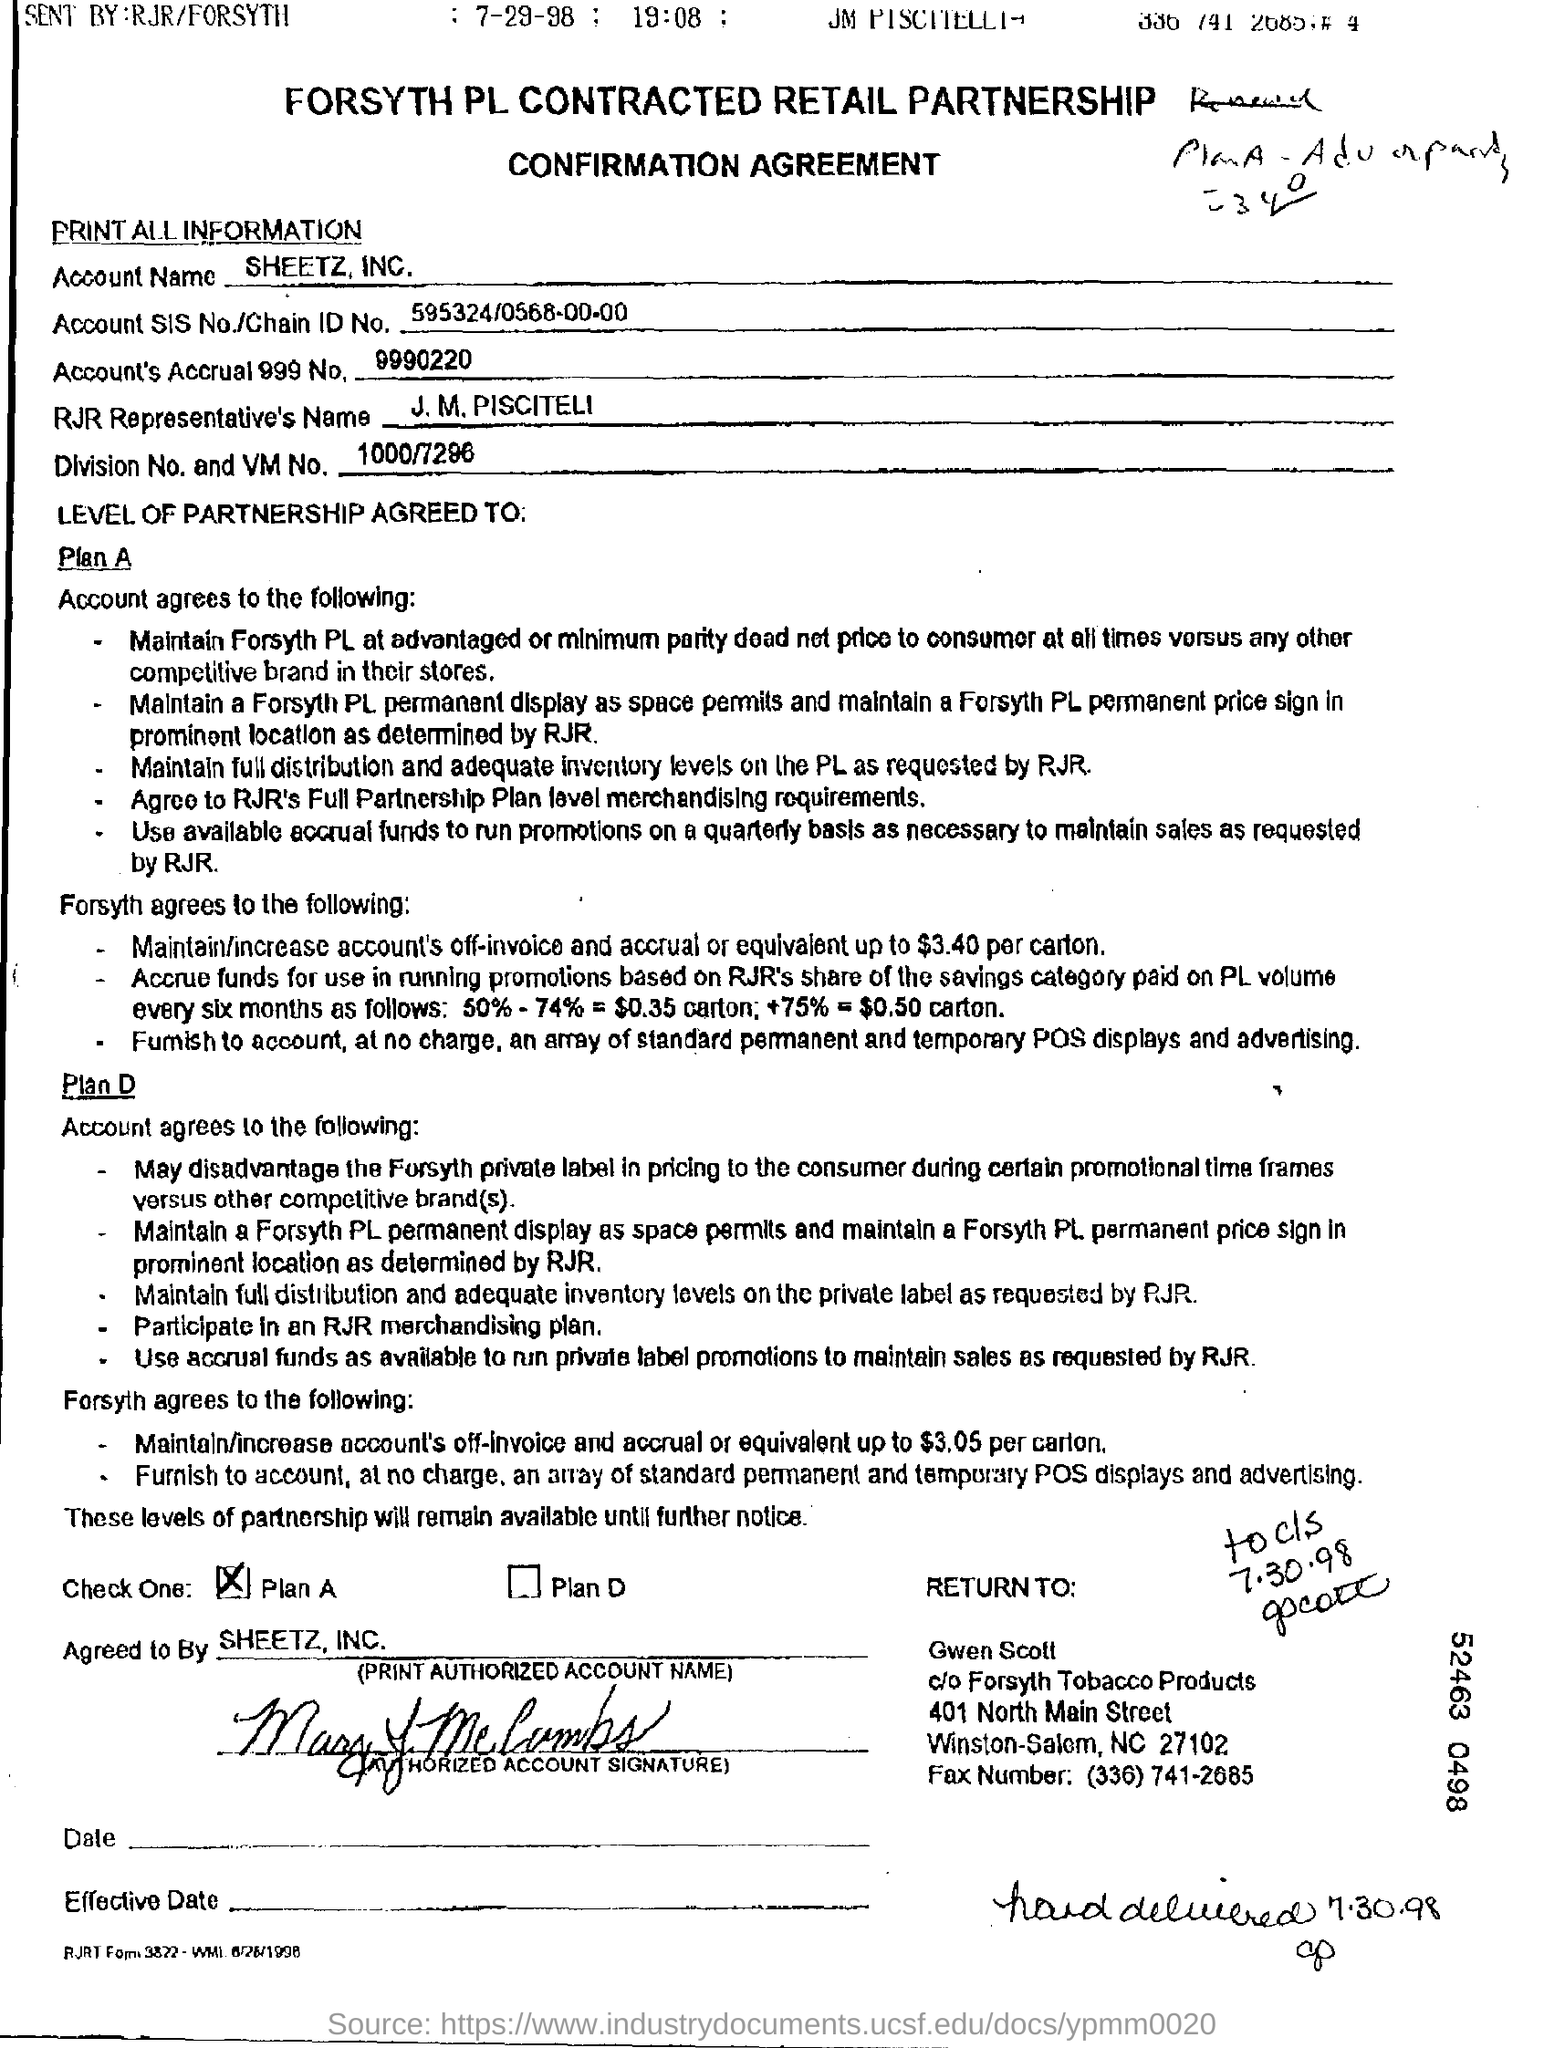Highlight a few significant elements in this photo. The account name is SHEETZ, INC. 